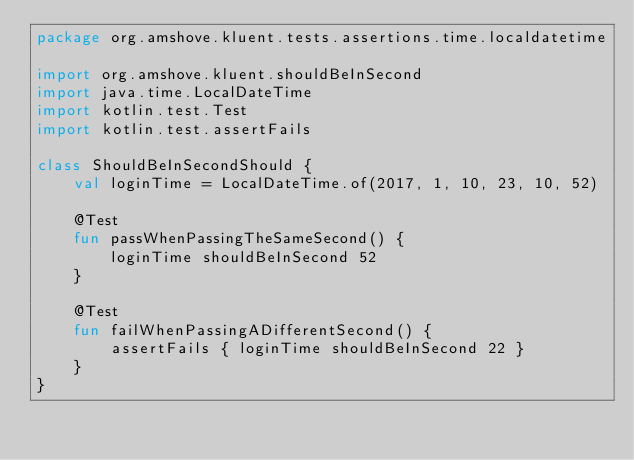<code> <loc_0><loc_0><loc_500><loc_500><_Kotlin_>package org.amshove.kluent.tests.assertions.time.localdatetime

import org.amshove.kluent.shouldBeInSecond
import java.time.LocalDateTime
import kotlin.test.Test
import kotlin.test.assertFails

class ShouldBeInSecondShould {
    val loginTime = LocalDateTime.of(2017, 1, 10, 23, 10, 52)

    @Test
    fun passWhenPassingTheSameSecond() {
        loginTime shouldBeInSecond 52
    }

    @Test
    fun failWhenPassingADifferentSecond() {
        assertFails { loginTime shouldBeInSecond 22 }
    }
}

</code> 